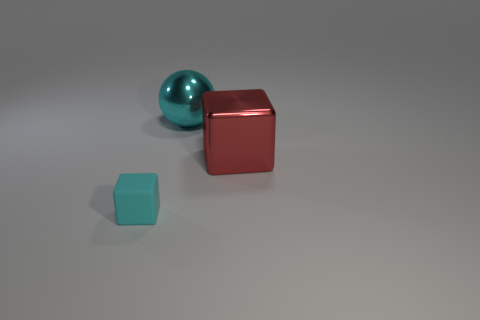Is the number of cyan blocks that are behind the small cyan cube greater than the number of shiny cylinders?
Offer a terse response. No. Are there any other things that are the same size as the shiny sphere?
Offer a terse response. Yes. Do the large block and the block that is left of the large sphere have the same color?
Your response must be concise. No. Are there the same number of shiny objects that are in front of the large cube and shiny cubes in front of the small cyan block?
Ensure brevity in your answer.  Yes. What is the material of the cyan object in front of the cyan metal object?
Offer a terse response. Rubber. How many objects are things in front of the large cyan metallic object or big cyan metal things?
Offer a very short reply. 3. What number of other objects are the same shape as the small cyan thing?
Give a very brief answer. 1. There is a cyan object behind the big red thing; is its shape the same as the big red metallic thing?
Provide a succinct answer. No. There is a big cyan object; are there any cyan cubes in front of it?
Provide a short and direct response. Yes. What number of tiny things are purple shiny spheres or red cubes?
Keep it short and to the point. 0. 